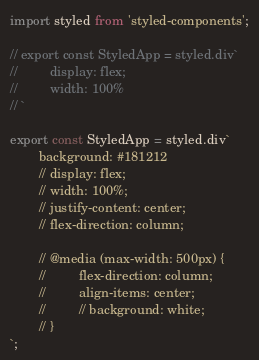Convert code to text. <code><loc_0><loc_0><loc_500><loc_500><_JavaScript_>import styled from 'styled-components';

// export const StyledApp = styled.div`
//         display: flex;
//         width: 100%  
// `

export const StyledApp = styled.div`
        background: #181212
        // display: flex;
        // width: 100%;
        // justify-content: center;
        // flex-direction: column;
        
        // @media (max-width: 500px) {
        //         flex-direction: column;
        //         align-items: center;
        //         // background: white;
        // }
`;</code> 